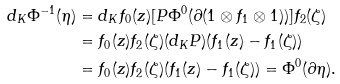<formula> <loc_0><loc_0><loc_500><loc_500>d _ { K } \Phi ^ { - 1 } ( \eta ) & = d _ { K } f _ { 0 } ( z ) [ P \Phi ^ { 0 } ( \partial ( 1 \otimes f _ { 1 } \otimes 1 ) ) ] f _ { 2 } ( \zeta ) \\ & = f _ { 0 } ( z ) f _ { 2 } ( \zeta ) ( d _ { K } P ) ( f _ { 1 } ( z ) - f _ { 1 } ( \zeta ) ) \\ & = f _ { 0 } ( z ) f _ { 2 } ( \zeta ) ( f _ { 1 } ( z ) - f _ { 1 } ( \zeta ) ) = \Phi ^ { 0 } ( \partial \eta ) .</formula> 